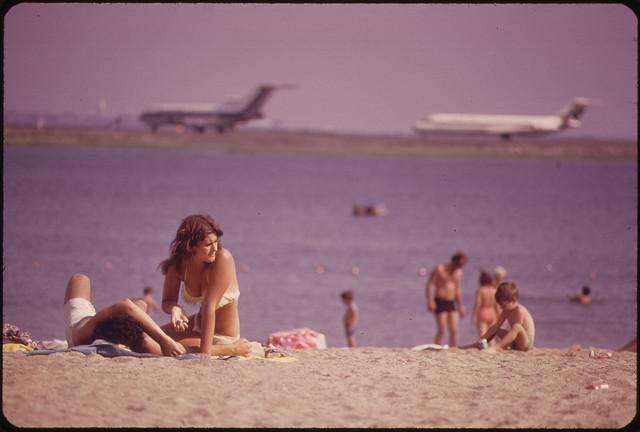How many people are there?
Give a very brief answer. 4. How many airplanes are in the photo?
Give a very brief answer. 2. How many rolls of toilet paper are on the toilet?
Give a very brief answer. 0. 